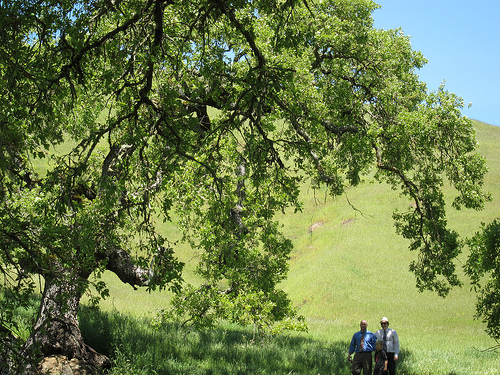<image>
Is the man on the grass? Yes. Looking at the image, I can see the man is positioned on top of the grass, with the grass providing support. 